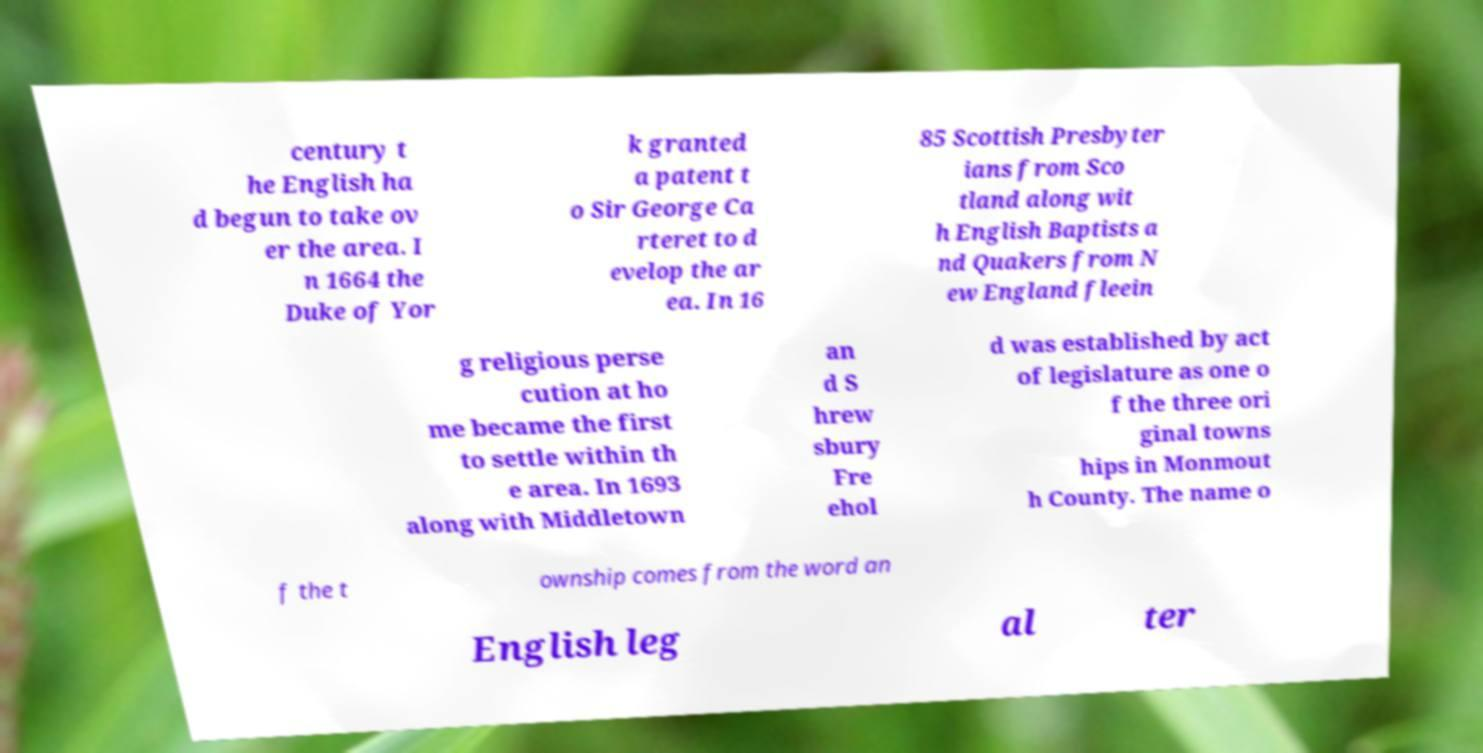Please identify and transcribe the text found in this image. century t he English ha d begun to take ov er the area. I n 1664 the Duke of Yor k granted a patent t o Sir George Ca rteret to d evelop the ar ea. In 16 85 Scottish Presbyter ians from Sco tland along wit h English Baptists a nd Quakers from N ew England fleein g religious perse cution at ho me became the first to settle within th e area. In 1693 along with Middletown an d S hrew sbury Fre ehol d was established by act of legislature as one o f the three ori ginal towns hips in Monmout h County. The name o f the t ownship comes from the word an English leg al ter 